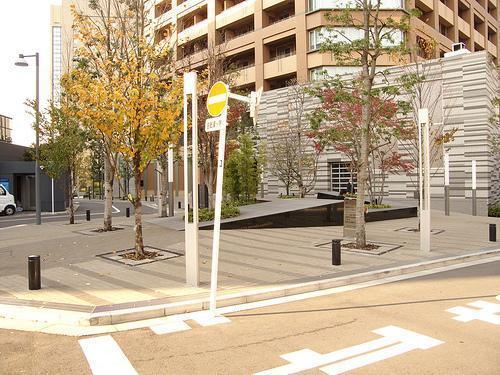How many cars are driving on the road?
Give a very brief answer. 0. 